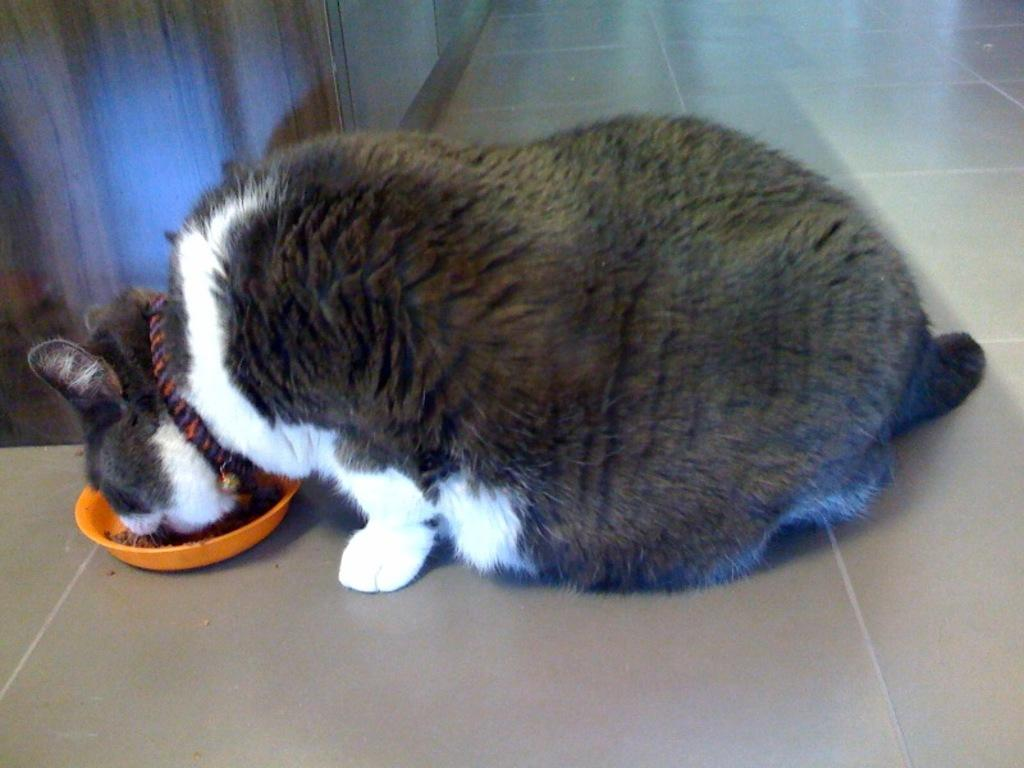What animal is present in the image? There is a cat in the image. What is the cat doing in the image? The cat is eating food in the image. Where is the food located? The food is in a bowl in the image. What can be seen in the background of the image? There is a cupboard in the background of the image. What type of flooring is visible in the image? The floor has marble tiles in the image. Where is the vase placed in the image? There is no vase present in the image. What type of sponge is being used by the cat to eat the food? The cat is not using a sponge to eat the food; it is using its mouth and paws. 